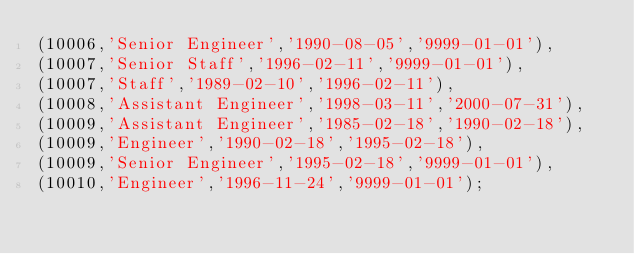Convert code to text. <code><loc_0><loc_0><loc_500><loc_500><_SQL_>(10006,'Senior Engineer','1990-08-05','9999-01-01'),
(10007,'Senior Staff','1996-02-11','9999-01-01'),
(10007,'Staff','1989-02-10','1996-02-11'),
(10008,'Assistant Engineer','1998-03-11','2000-07-31'),
(10009,'Assistant Engineer','1985-02-18','1990-02-18'),
(10009,'Engineer','1990-02-18','1995-02-18'),
(10009,'Senior Engineer','1995-02-18','9999-01-01'),
(10010,'Engineer','1996-11-24','9999-01-01');</code> 